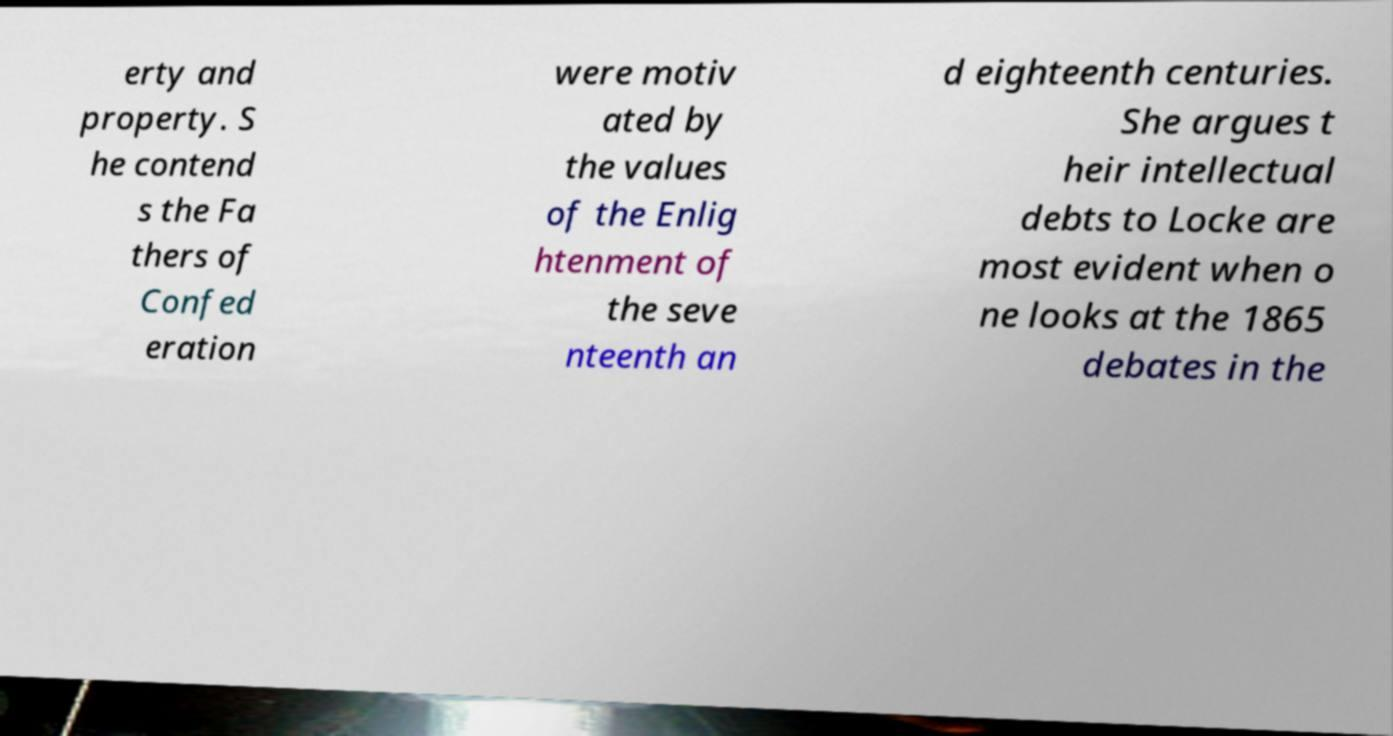Could you extract and type out the text from this image? erty and property. S he contend s the Fa thers of Confed eration were motiv ated by the values of the Enlig htenment of the seve nteenth an d eighteenth centuries. She argues t heir intellectual debts to Locke are most evident when o ne looks at the 1865 debates in the 